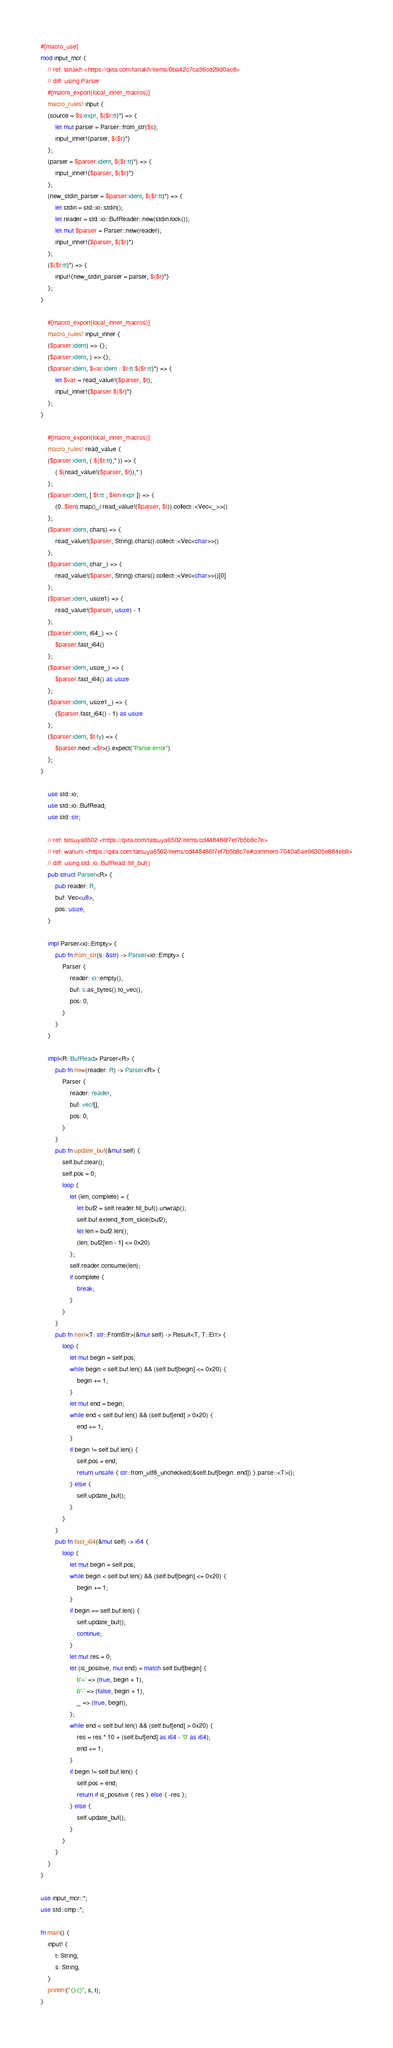<code> <loc_0><loc_0><loc_500><loc_500><_Rust_>#[macro_use]
mod input_mcr {
    // ref: tanakh <https://qiita.com/tanakh/items/0ba42c7ca36cd29d0ac8>
    // diff: using Parser
    #[macro_export(local_inner_macros)]
    macro_rules! input {
    (source = $s:expr, $($r:tt)*) => {
        let mut parser = Parser::from_str($s);
        input_inner!{parser, $($r)*}
    };
    (parser = $parser:ident, $($r:tt)*) => {
        input_inner!{$parser, $($r)*}
    };
    (new_stdin_parser = $parser:ident, $($r:tt)*) => {
        let stdin = std::io::stdin();
        let reader = std::io::BufReader::new(stdin.lock());
        let mut $parser = Parser::new(reader);
        input_inner!{$parser, $($r)*}
    };
    ($($r:tt)*) => {
        input!{new_stdin_parser = parser, $($r)*}
    };
}

    #[macro_export(local_inner_macros)]
    macro_rules! input_inner {
    ($parser:ident) => {};
    ($parser:ident, ) => {};
    ($parser:ident, $var:ident : $t:tt $($r:tt)*) => {
        let $var = read_value!($parser, $t);
        input_inner!{$parser $($r)*}
    };
}

    #[macro_export(local_inner_macros)]
    macro_rules! read_value {
    ($parser:ident, ( $($t:tt),* )) => {
        ( $(read_value!($parser, $t)),* )
    };
    ($parser:ident, [ $t:tt ; $len:expr ]) => {
        (0..$len).map(|_| read_value!($parser, $t)).collect::<Vec<_>>()
    };
    ($parser:ident, chars) => {
        read_value!($parser, String).chars().collect::<Vec<char>>()
    };
    ($parser:ident, char_) => {
        read_value!($parser, String).chars().collect::<Vec<char>>()[0]
    };
    ($parser:ident, usize1) => {
        read_value!($parser, usize) - 1
    };
    ($parser:ident, i64_) => {
        $parser.fast_i64()
    };
    ($parser:ident, usize_) => {
        $parser.fast_i64() as usize
    };
    ($parser:ident, usize1_) => {
        ($parser.fast_i64() - 1) as usize
    };
    ($parser:ident, $t:ty) => {
        $parser.next::<$t>().expect("Parse error")
    };
}

    use std::io;
    use std::io::BufRead;
    use std::str;

    // ref: tatsuya6502 <https://qiita.com/tatsuya6502/items/cd448486f7ef7b5b8c7e>
    // ref: wariuni <https://qiita.com/tatsuya6502/items/cd448486f7ef7b5b8c7e#comment-7040a5ae96305e884eb9>
    // diff: using std::io::BufRead::fill_buf()
    pub struct Parser<R> {
        pub reader: R,
        buf: Vec<u8>,
        pos: usize,
    }

    impl Parser<io::Empty> {
        pub fn from_str(s: &str) -> Parser<io::Empty> {
            Parser {
                reader: io::empty(),
                buf: s.as_bytes().to_vec(),
                pos: 0,
            }
        }
    }

    impl<R: BufRead> Parser<R> {
        pub fn new(reader: R) -> Parser<R> {
            Parser {
                reader: reader,
                buf: vec![],
                pos: 0,
            }
        }
        pub fn update_buf(&mut self) {
            self.buf.clear();
            self.pos = 0;
            loop {
                let (len, complete) = {
                    let buf2 = self.reader.fill_buf().unwrap();
                    self.buf.extend_from_slice(buf2);
                    let len = buf2.len();
                    (len, buf2[len - 1] <= 0x20)
                };
                self.reader.consume(len);
                if complete {
                    break;
                }
            }
        }
        pub fn next<T: str::FromStr>(&mut self) -> Result<T, T::Err> {
            loop {
                let mut begin = self.pos;
                while begin < self.buf.len() && (self.buf[begin] <= 0x20) {
                    begin += 1;
                }
                let mut end = begin;
                while end < self.buf.len() && (self.buf[end] > 0x20) {
                    end += 1;
                }
                if begin != self.buf.len() {
                    self.pos = end;
                    return unsafe { str::from_utf8_unchecked(&self.buf[begin..end]) }.parse::<T>();
                } else {
                    self.update_buf();
                }
            }
        }
        pub fn fast_i64(&mut self) -> i64 {
            loop {
                let mut begin = self.pos;
                while begin < self.buf.len() && (self.buf[begin] <= 0x20) {
                    begin += 1;
                }
                if begin == self.buf.len() {
                    self.update_buf();
                    continue;
                }
                let mut res = 0;
                let (is_positive, mut end) = match self.buf[begin] {
                    b'+' => (true, begin + 1),
                    b'-' => (false, begin + 1),
                    _ => (true, begin),
                };
                while end < self.buf.len() && (self.buf[end] > 0x20) {
                    res = res * 10 + (self.buf[end] as i64 - '0' as i64);
                    end += 1;
                }
                if begin != self.buf.len() {
                    self.pos = end;
                    return if is_positive { res } else { -res };
                } else {
                    self.update_buf();
                }
            }
        }
    }
}

use input_mcr::*;
use std::cmp::*;

fn main() {
    input! {
        t: String,
        s: String,
    }
    println!("{}{}", s, t);
}

</code> 